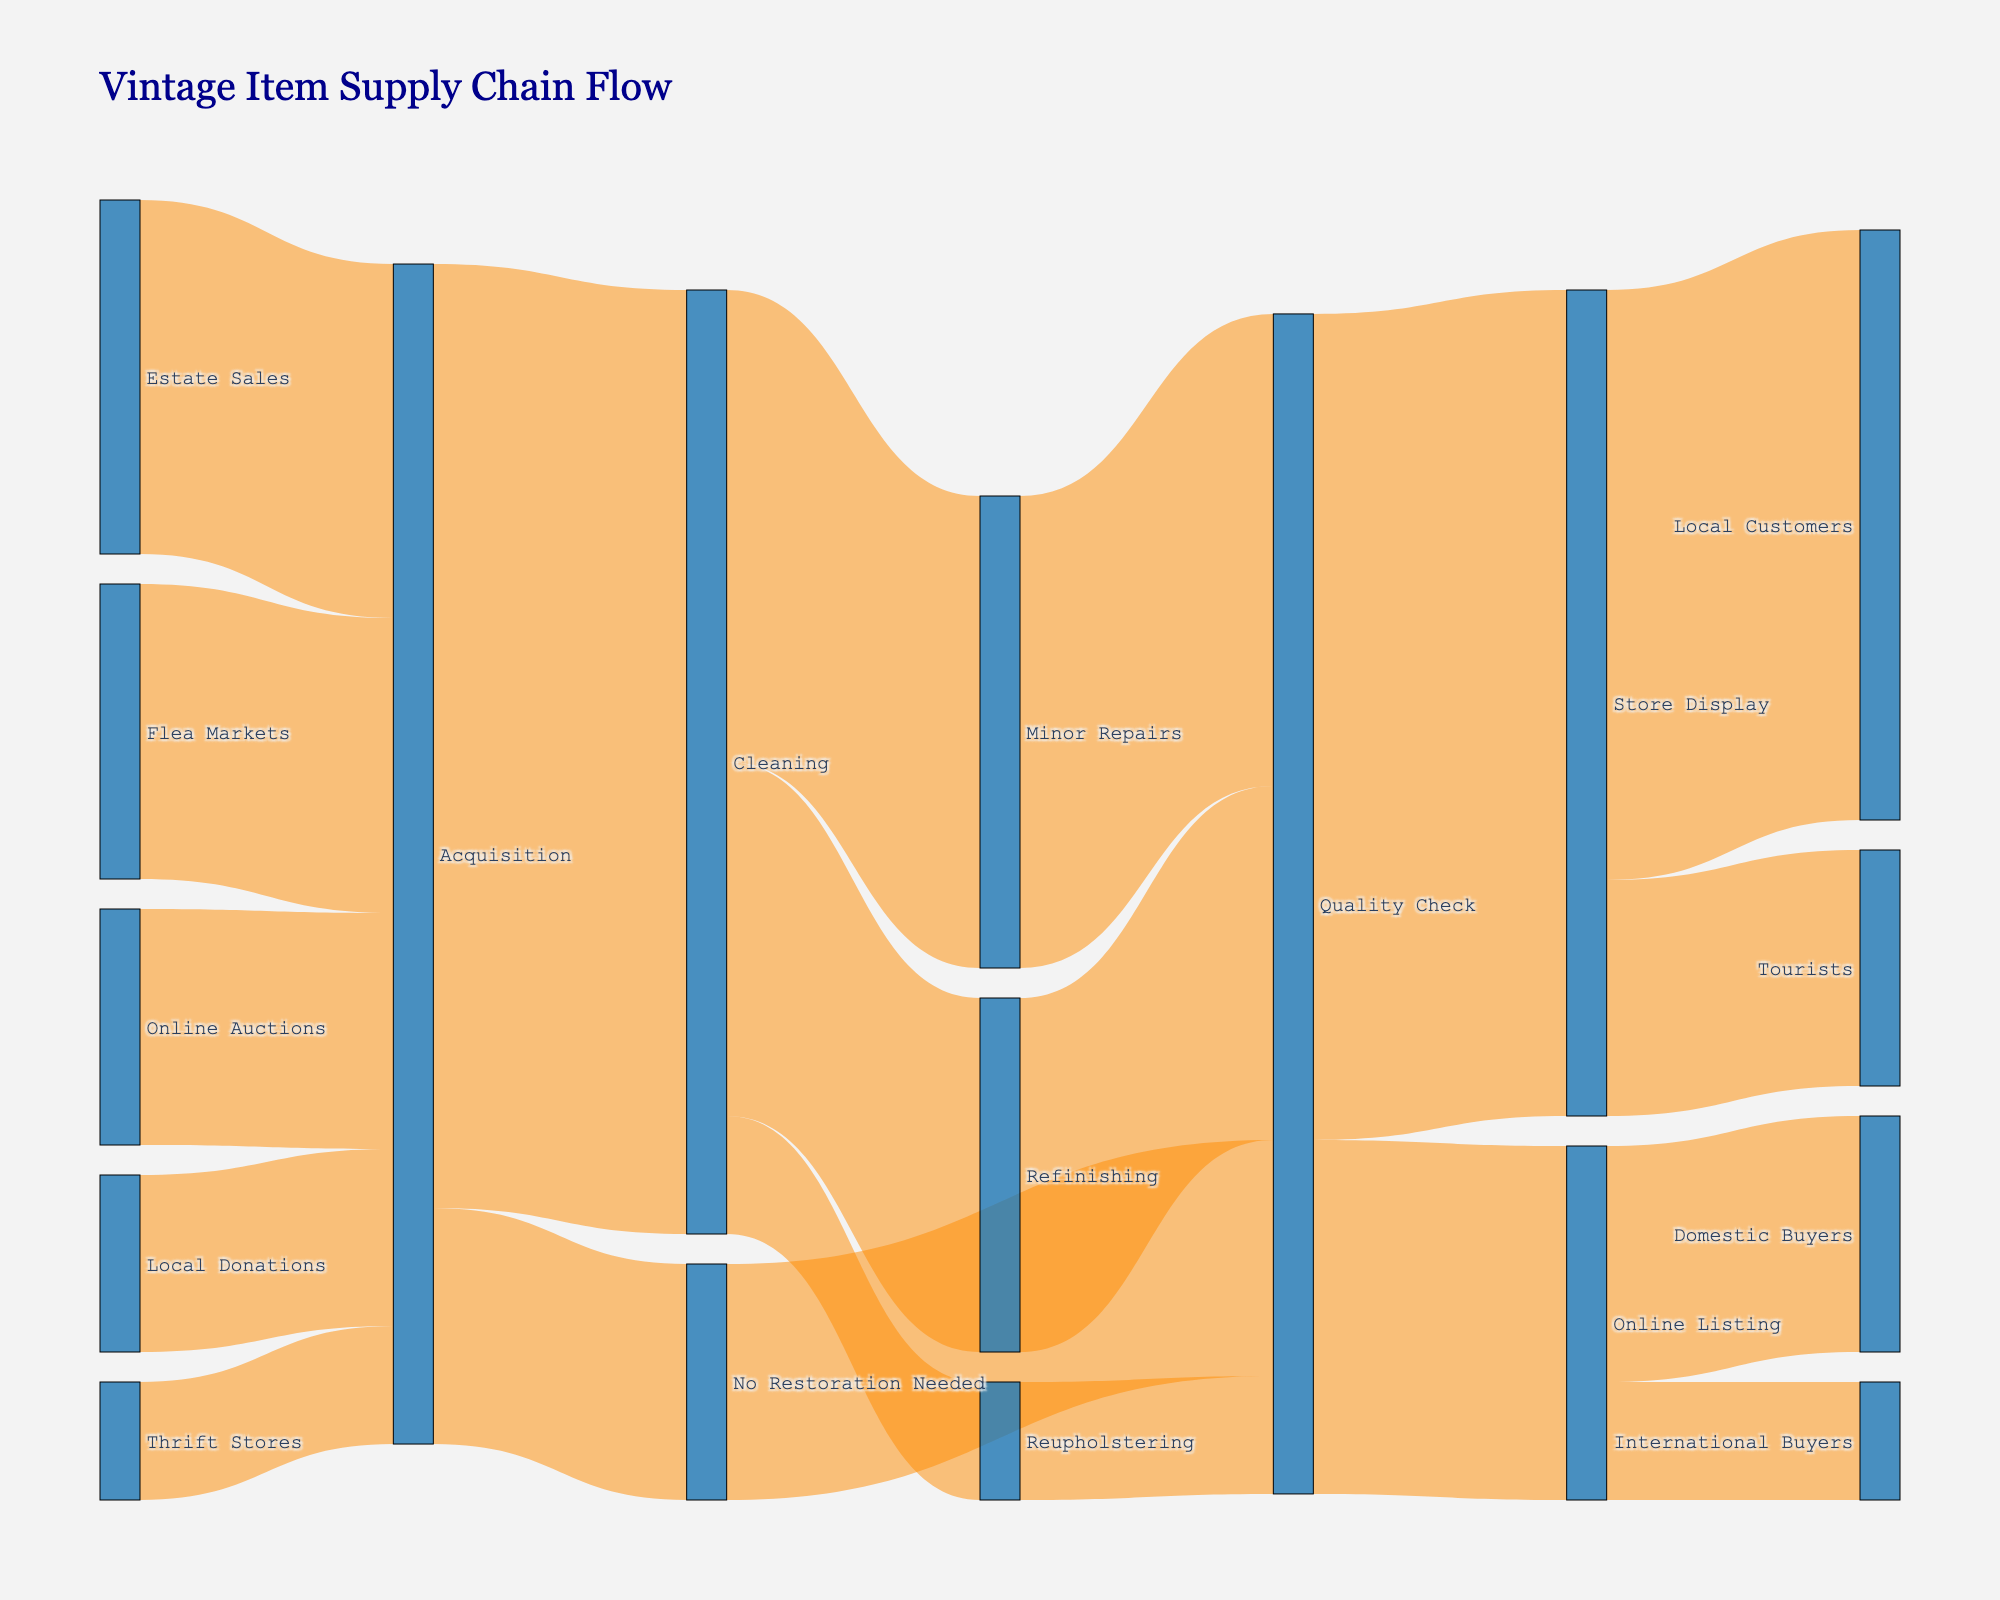How many vintage items are acquired from Estate Sales? The flow from "Estate Sales" to "Acquisition" shows a value of 30, indicating 30 items are acquired from Estate Sales.
Answer: 30 What are the two least common sources of vintage item acquisitions? The flows to "Acquisition" from different sources show the values: Estate Sales (30), Flea Markets (25), Online Auctions (20), Local Donations (15), Thrift Stores (10). The least common sources are Thrift Stores (10) and Local Donations (15).
Answer: Thrift Stores and Local Donations Which restoration process handles the most items after cleaning? The flows from "Cleaning" show values: Minor Repairs (40), Refinishing (30), Reupholstering (10). Minor Repairs handles the most with 40 items.
Answer: Minor Repairs How many items go through the Cleaning process? The flow from "Acquisition" to "Cleaning" shows a value of 80, which means 80 items go through the Cleaning process.
Answer: 80 What is the total number of items that undergo some form of restoration after acquisition? Items going through restoration are: Cleaning (80) and No Restoration Needed (20). Summing up, we have 80 + 20 = 100, but out of those, 20 require no restoration, so 80 items undergo some restoration.
Answer: 80 Which category serves the highest number of local customers? From "Store Display" to "Local Customers" the value is 50, and from "Online Listing" to "Domestic Buyers" the value is 20. Therefore, "Store Display" serves 50 local customers, which is the highest.
Answer: Store Display How many items are available to international buyers? From "Online Listing" to "International Buyers," the value is 10, indicating there are 10 items available to international buyers.
Answer: 10 Which stage directly follows minor repairs in the supply chain? The flow from "Minor Repairs" shows it leads to "Quality Check" with a value of 40.
Answer: Quality Check What's the combined total of items that end up for sale in the store or online? The flows show 70 items to "Store Display" and 30 items to "Online Listing", summing up to 70 + 30 = 100.
Answer: 100 How many items go from Quality Check to their final placement? The flows show values going from Quality Check to Store Display (70) and Online Listing (30), summing up to 70 + 30 = 100 items reaching their final placement after Quality Check.
Answer: 100 